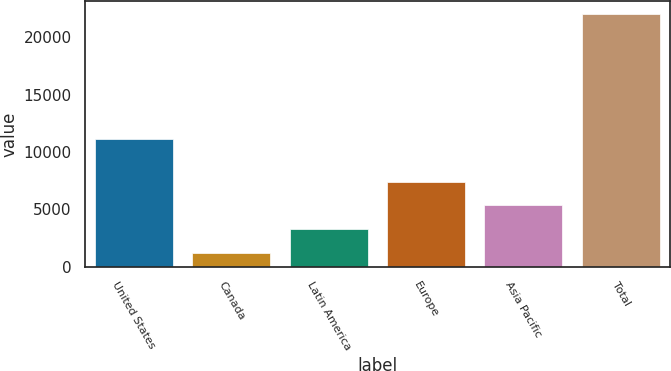Convert chart to OTSL. <chart><loc_0><loc_0><loc_500><loc_500><bar_chart><fcel>United States<fcel>Canada<fcel>Latin America<fcel>Europe<fcel>Asia Pacific<fcel>Total<nl><fcel>11092<fcel>1154<fcel>3243.2<fcel>7421.6<fcel>5332.4<fcel>22046<nl></chart> 